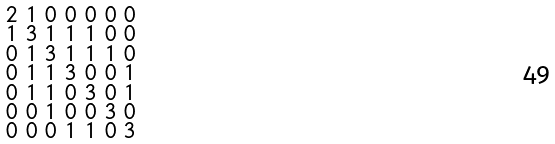<formula> <loc_0><loc_0><loc_500><loc_500>\begin{smallmatrix} 2 & 1 & 0 & 0 & 0 & 0 & 0 \\ 1 & 3 & 1 & 1 & 1 & 0 & 0 \\ 0 & 1 & 3 & 1 & 1 & 1 & 0 \\ 0 & 1 & 1 & 3 & 0 & 0 & 1 \\ 0 & 1 & 1 & 0 & 3 & 0 & 1 \\ 0 & 0 & 1 & 0 & 0 & 3 & 0 \\ 0 & 0 & 0 & 1 & 1 & 0 & 3 \end{smallmatrix}</formula> 